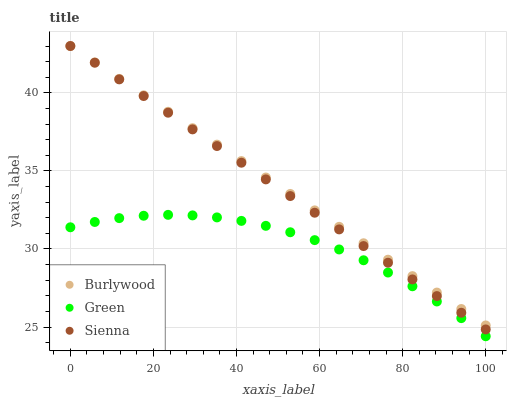Does Green have the minimum area under the curve?
Answer yes or no. Yes. Does Burlywood have the maximum area under the curve?
Answer yes or no. Yes. Does Sienna have the minimum area under the curve?
Answer yes or no. No. Does Sienna have the maximum area under the curve?
Answer yes or no. No. Is Sienna the smoothest?
Answer yes or no. Yes. Is Green the roughest?
Answer yes or no. Yes. Is Green the smoothest?
Answer yes or no. No. Is Sienna the roughest?
Answer yes or no. No. Does Green have the lowest value?
Answer yes or no. Yes. Does Sienna have the lowest value?
Answer yes or no. No. Does Sienna have the highest value?
Answer yes or no. Yes. Does Green have the highest value?
Answer yes or no. No. Is Green less than Burlywood?
Answer yes or no. Yes. Is Burlywood greater than Green?
Answer yes or no. Yes. Does Burlywood intersect Sienna?
Answer yes or no. Yes. Is Burlywood less than Sienna?
Answer yes or no. No. Is Burlywood greater than Sienna?
Answer yes or no. No. Does Green intersect Burlywood?
Answer yes or no. No. 